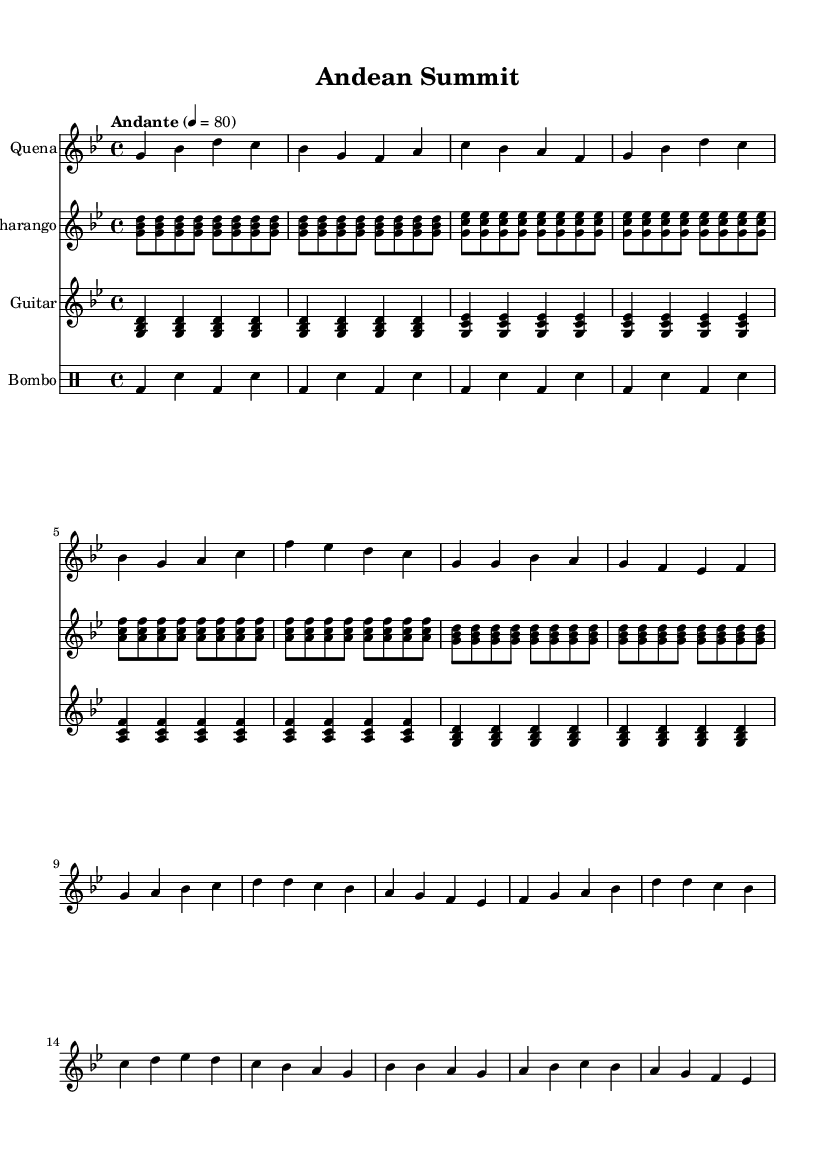What is the key signature of this music? The key signature is G minor, which has two flats: B flat and E flat. You can identify the key signature by looking at the beginning of the staff where the flats are placed.
Answer: G minor What is the time signature of this music? The time signature is 4/4, indicating there are four beats in each measure, and the quarter note gets one beat. This is confirmed by the numbers displayed at the beginning of the score.
Answer: 4/4 What is the tempo marking for this piece? The tempo marking is "Andante," which indicates a moderate walking pace, often understood to be around 76 to 108 beats per minute. This marking is indicated at the start of the score where the tempo is described.
Answer: Andante How many times does the charango pattern repeat? The charango pattern repeats a total of 12 times; there are 4 repetitions of each of its 3 sections in \( \relative \) notation, clearly noted within the repetitive structure.
Answer: 12 Which instrument plays the melodic line prominently? The Quena plays the melodic line prominently as it is the first staff mentioned and clearly shows a distinct melody. The notation under the "Quena" staff indicates it carries the primary theme throughout the score.
Answer: Quena What is the function of the bombo in this piece? The bombo acts as a rhythmic foundation providing percussion and marked beat, which is shown by its notation consisting of bass drum sounds and snare hits in a consistent pattern through the piece.
Answer: Rhythmic foundation 